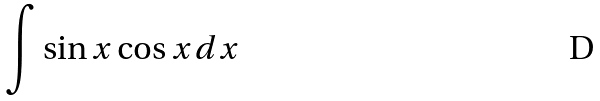<formula> <loc_0><loc_0><loc_500><loc_500>\int \sin x \cos x d x</formula> 